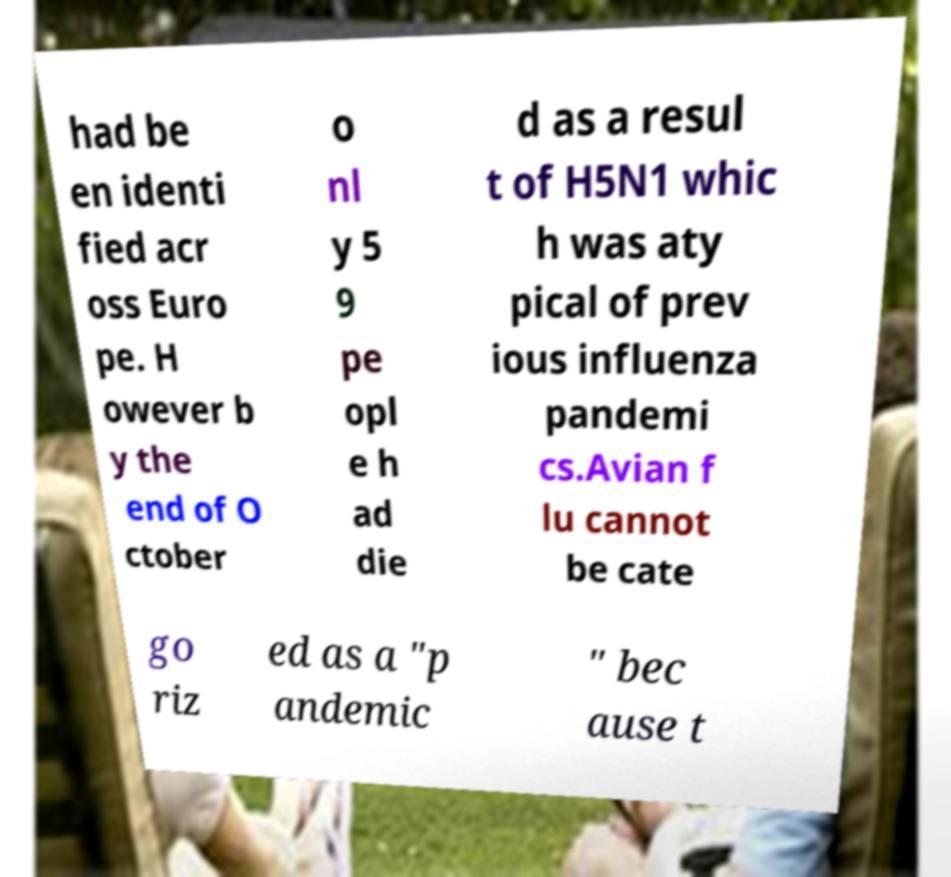Please identify and transcribe the text found in this image. had be en identi fied acr oss Euro pe. H owever b y the end of O ctober o nl y 5 9 pe opl e h ad die d as a resul t of H5N1 whic h was aty pical of prev ious influenza pandemi cs.Avian f lu cannot be cate go riz ed as a "p andemic " bec ause t 